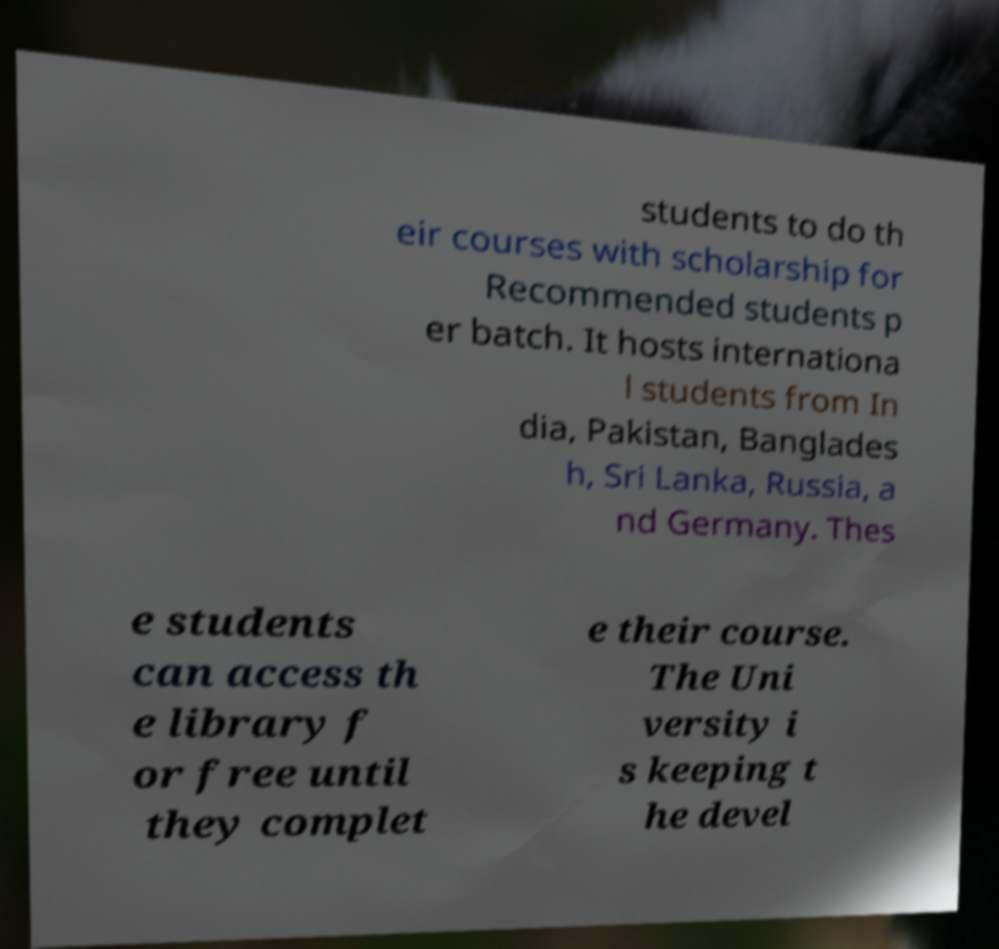Can you accurately transcribe the text from the provided image for me? students to do th eir courses with scholarship for Recommended students p er batch. It hosts internationa l students from In dia, Pakistan, Banglades h, Sri Lanka, Russia, a nd Germany. Thes e students can access th e library f or free until they complet e their course. The Uni versity i s keeping t he devel 